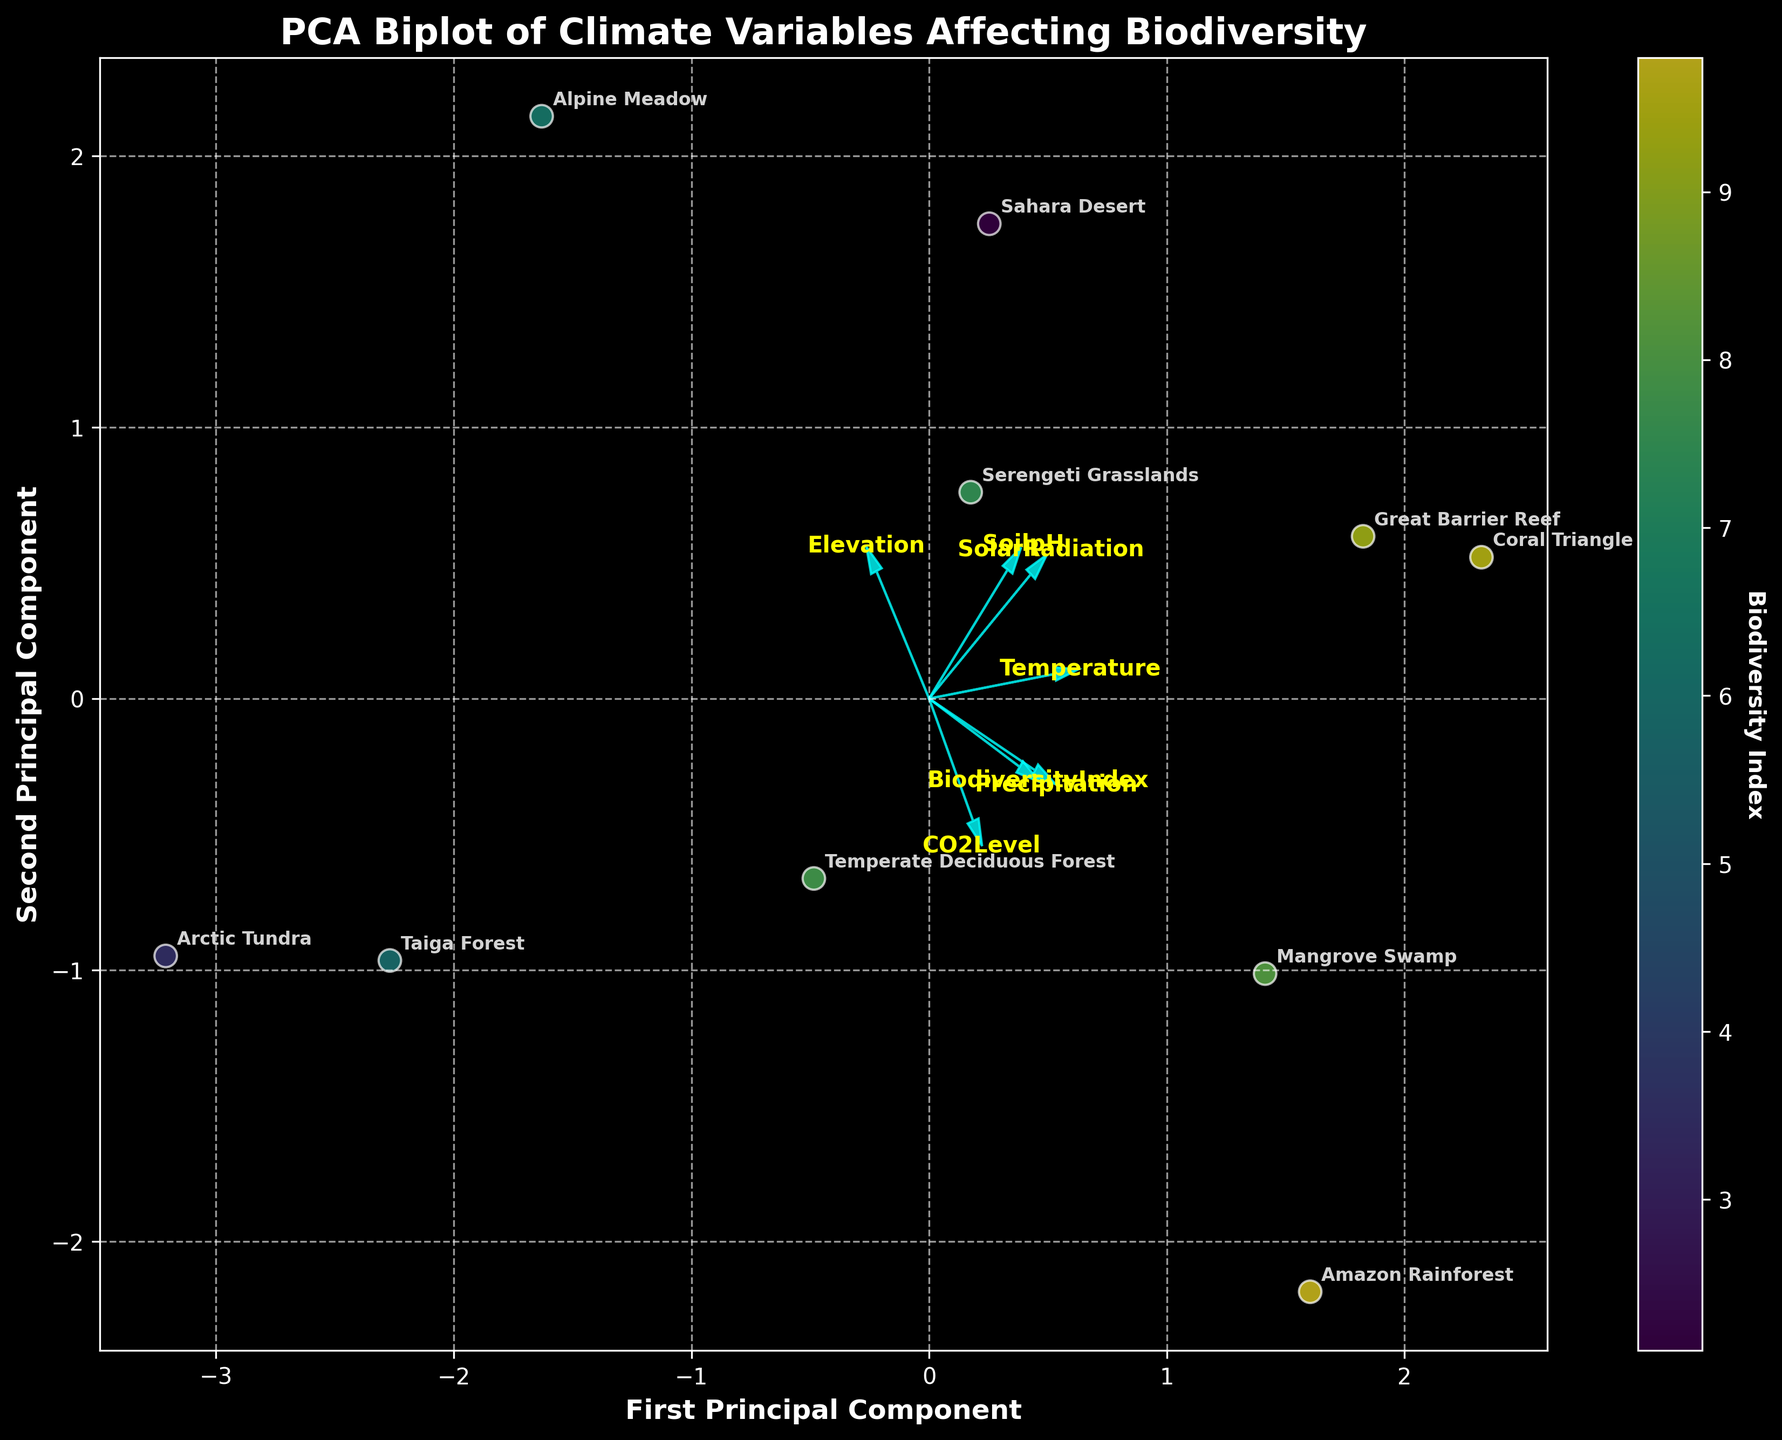What are the axes labeled as? The x-axis is labeled "First Principal Component" and the y-axis is labeled "Second Principal Component". These labels are used to represent the two main components derived from PCA that explain the most variance in the data.
Answer: First Principal Component on the x-axis and Second Principal Component on the y-axis How many biomes are represented in the plot? Each data point in the plot corresponds to a different biome. By counting the data points annotated with biome labels, we can determine the number of biomes.
Answer: 10 Which biome has the highest Biodiversity Index? The color intensity of the data points represents the Biodiversity Index. The point with the highest intensity corresponds to the Amazon Rainforest. This can also be confirmed by the annotations.
Answer: Amazon Rainforest What is the direction of the Solar Radiation vector? The Solar Radiation vector is represented by an arrow. This arrow points to the right and slightly upward, indicating its loading on both the first and second principal components.
Answer: Right and slightly upward Compare the vectors for Temperature and Precipitation. Which one has a larger magnitude? The lengths of the arrows represent the magnitude of each factor. By visually comparing the lengths, it is evident that the Temperature vector is longer than the Precipitation vector.
Answer: Temperature Which biomes are located near the origin of the plot? The points near the origin represent biomes with average values concerning the principal components. By checking the annotations, we can note that the Temperate Deciduous Forest and Taiga Forest are near the origin.
Answer: Temperate Deciduous Forest and Taiga Forest Considering the elevation vectors, which biome shows a significant influence from elevation? Examine the position of the points relative to the Elevation vector's arrow. The Serengeti Grasslands are notably further along the vector, indicating a higher influence.
Answer: Serengeti Grasslands What general trend can be observed regarding the Biodiversity Index and the first principal component? By observing the color gradient and its distribution along the first principal component axis, a general trend where higher Biodiversity Indexes are associated with higher values on the first principal component can be noted.
Answer: Higher Biodiversity Index correlates with higher values on the first principal component How does the CO2Level vector align relative to the first and second principal components? By examining the direction of the CO2Level vector, we can see that it points mainly to the right and slightly downward, indicating a stronger influence on the first principal component and a lesser influence on the second.
Answer: Mainly aligns with the first principal component What does the clustering of points indicate about the relationship among biomes? Points that cluster close together indicate biomes with similar characteristics based on the variables considered in the PCA. For example, the Amazon Rainforest and Mangrove Swamp are clustered, suggesting they share similar climate and biodiversity features.
Answer: Indicates similar characteristics among the biomes clustered together 